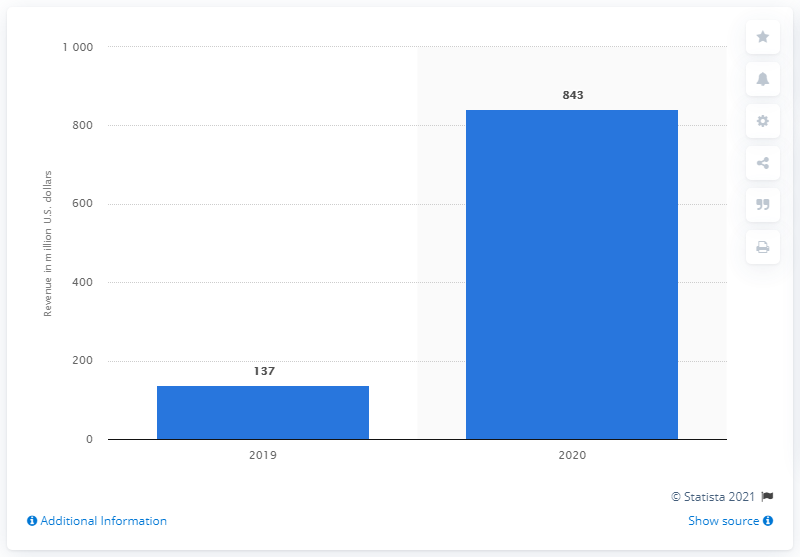Identify some key points in this picture. During the fiscal year ending March 28, 2020, Versace's global revenue was 843 million dollars. 